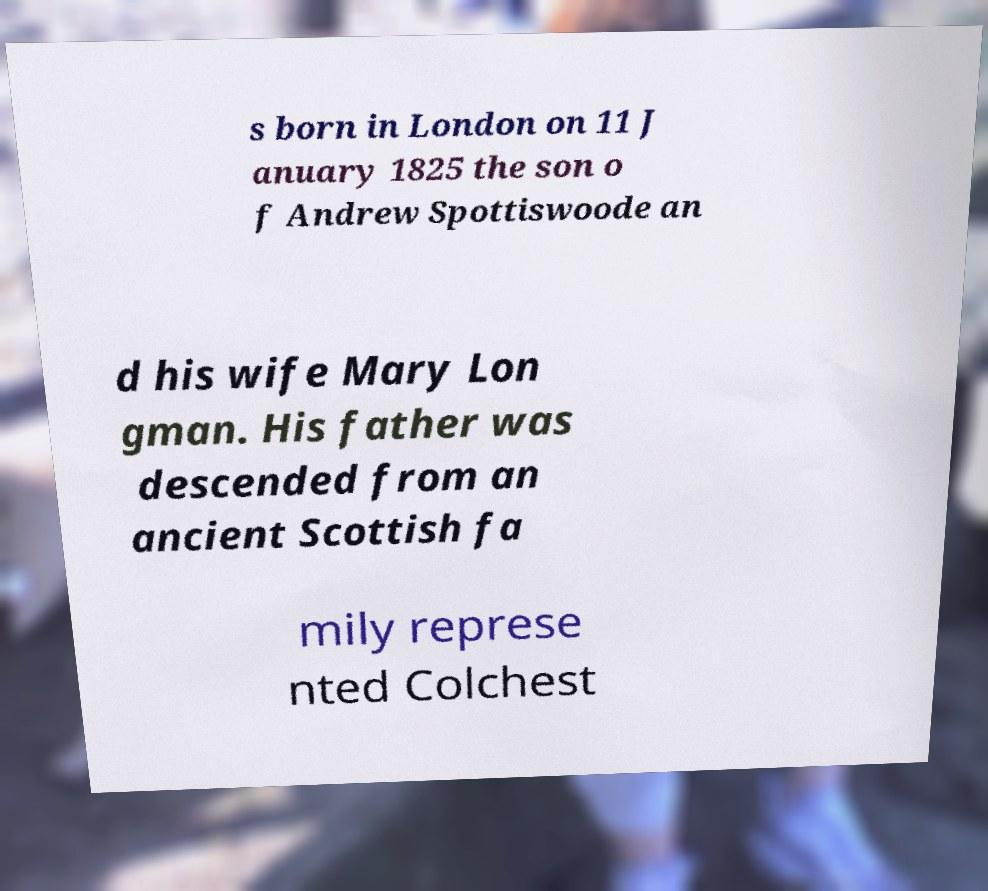There's text embedded in this image that I need extracted. Can you transcribe it verbatim? s born in London on 11 J anuary 1825 the son o f Andrew Spottiswoode an d his wife Mary Lon gman. His father was descended from an ancient Scottish fa mily represe nted Colchest 